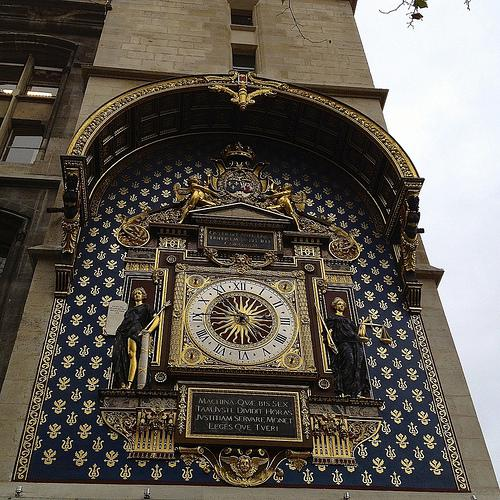Question: what color is the sun on the clock face?
Choices:
A. Orange.
B. Red.
C. Gold.
D. Pink.
Answer with the letter. Answer: C Question: what time does the clock show?
Choices:
A. 11:30.
B. 10:45.
C. 12:00.
D. 6:45.
Answer with the letter. Answer: B Question: what color is the accents on the blue tapestry?
Choices:
A. Gold.
B. Purple.
C. Maroon.
D. Red.
Answer with the letter. Answer: A Question: what is the hour hand pointed to?
Choices:
A. Ten o'clock.
B. Nine o'clock.
C. Seven o'clock.
D. Two o'clock.
Answer with the letter. Answer: A 